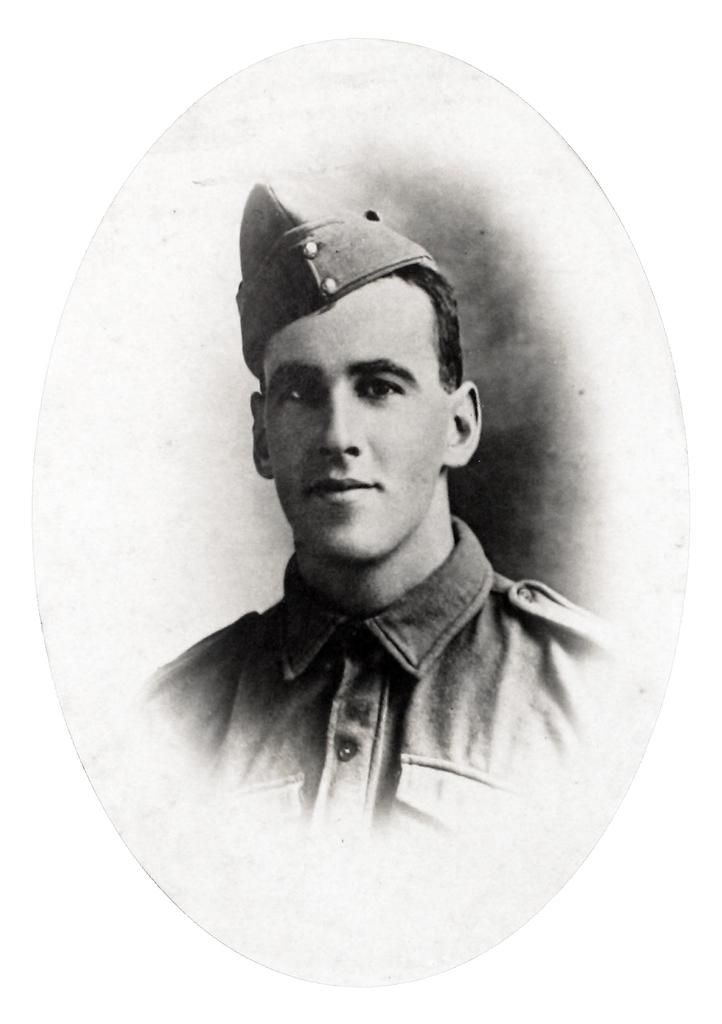What is the main subject of the image? There is a photo of a man in the image. What color is the background of the image? The background of the image is white. What type of punishment is being administered to the man in the image? There is no indication of punishment in the image; it only shows a photo of a man with a white background. What kind of lamp is present in the image? There is no lamp present in the image; it only shows a photo of a man with a white background. 